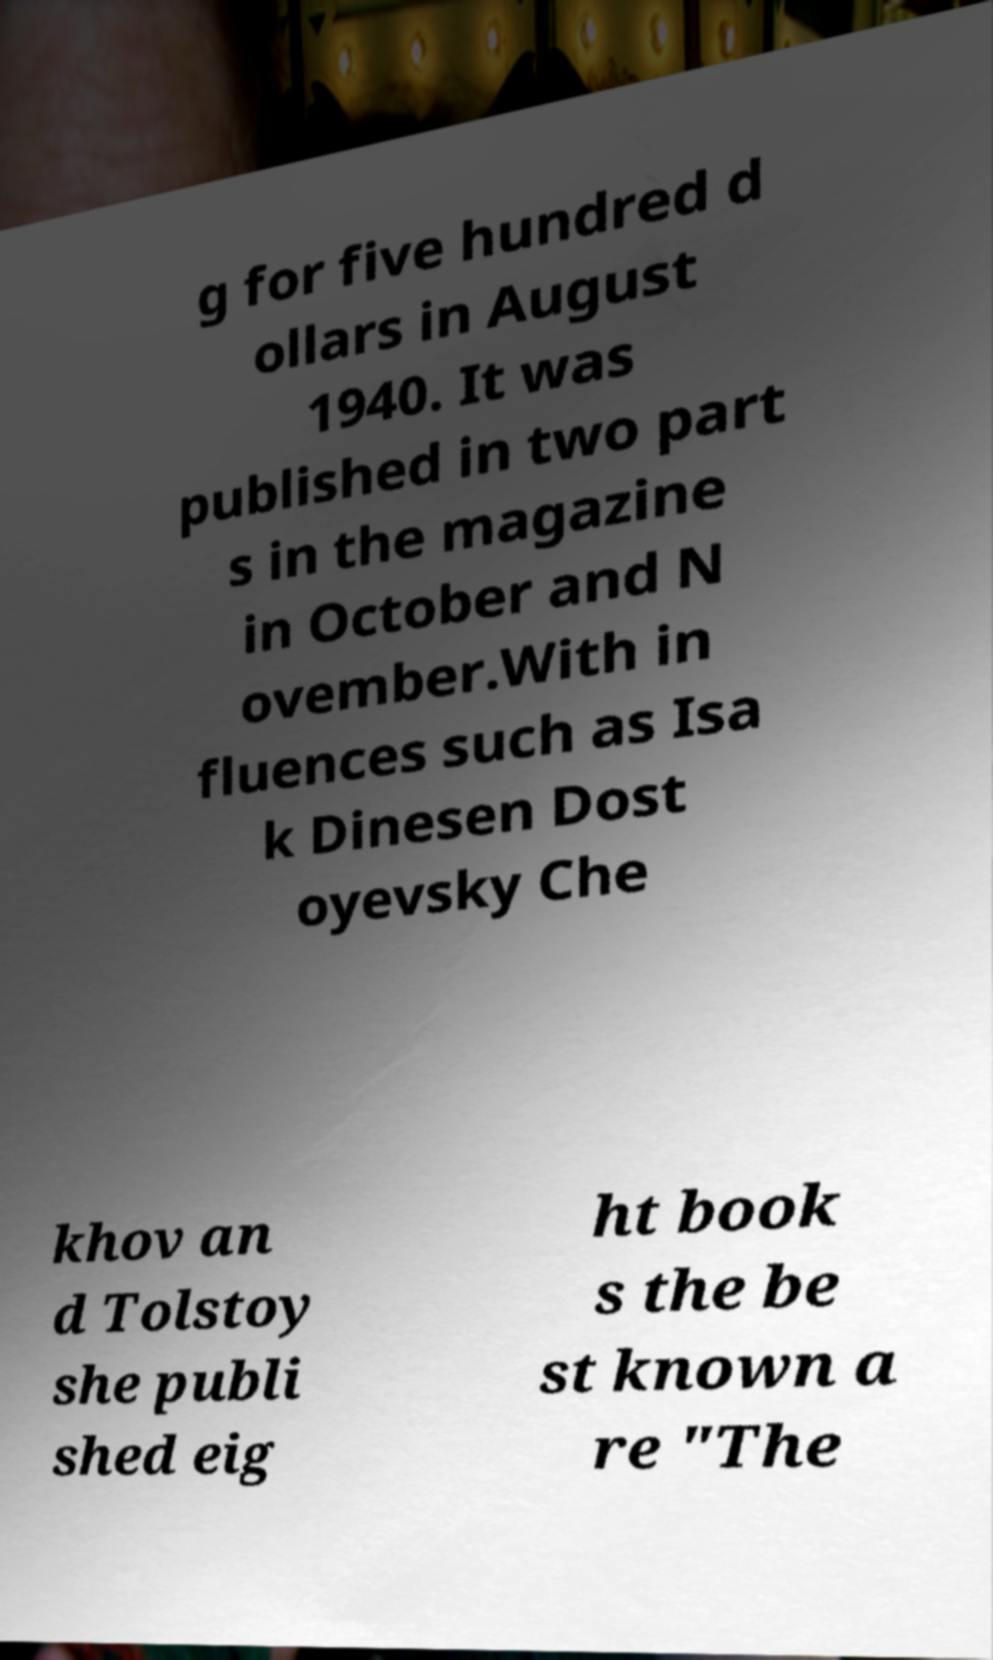What messages or text are displayed in this image? I need them in a readable, typed format. g for five hundred d ollars in August 1940. It was published in two part s in the magazine in October and N ovember.With in fluences such as Isa k Dinesen Dost oyevsky Che khov an d Tolstoy she publi shed eig ht book s the be st known a re "The 